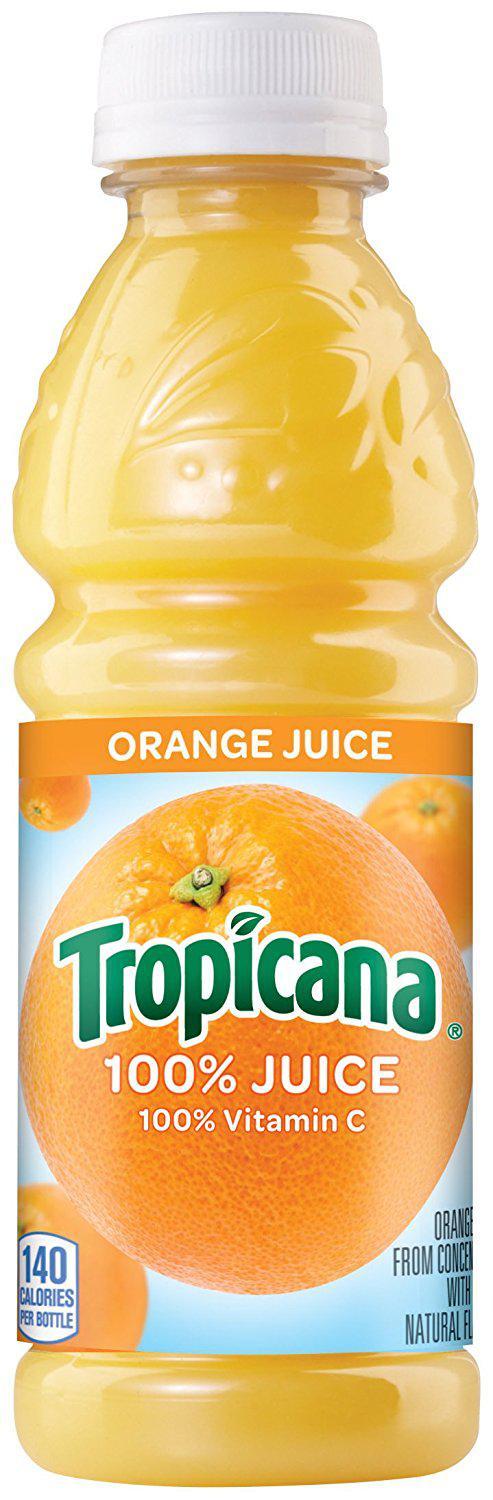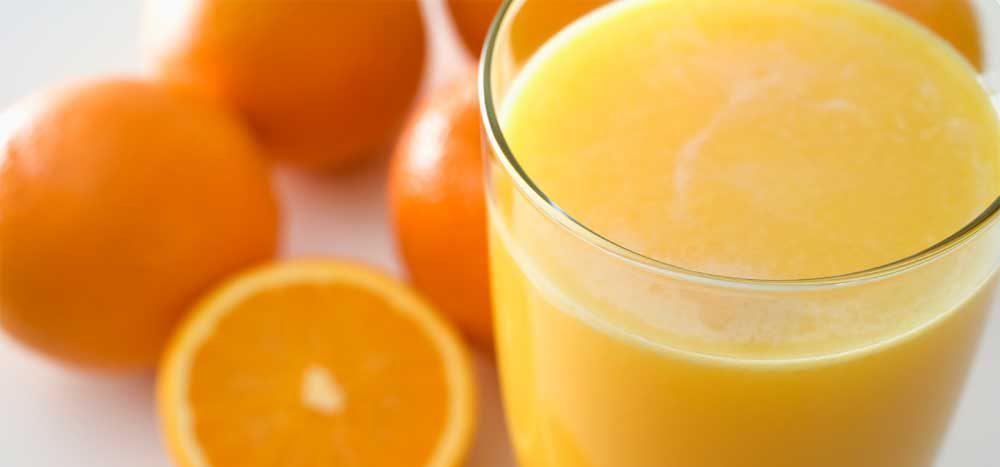The first image is the image on the left, the second image is the image on the right. Assess this claim about the two images: "Some of the oranges are cut into wedges, not just halves.". Correct or not? Answer yes or no. No. The first image is the image on the left, the second image is the image on the right. Given the left and right images, does the statement "Only one image contains the juice of the oranges." hold true? Answer yes or no. No. 